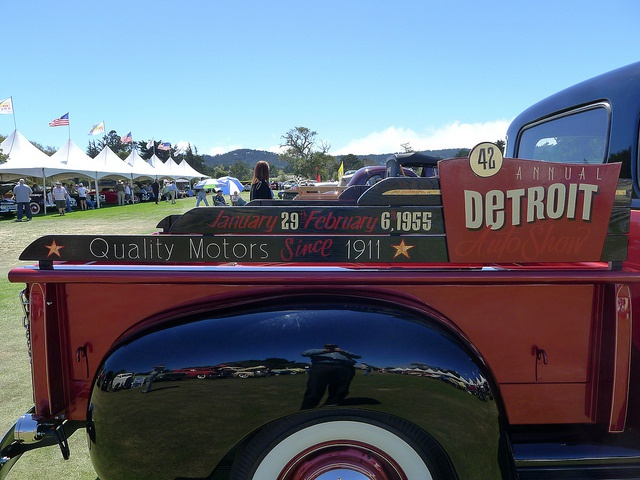Describe the objects in this image and their specific colors. I can see truck in lightblue, black, maroon, navy, and darkgray tones, people in lightblue, black, navy, blue, and gray tones, people in lightblue, black, gray, and darkgray tones, people in lightblue, black, gray, olive, and navy tones, and people in lightblue, gray, black, and navy tones in this image. 